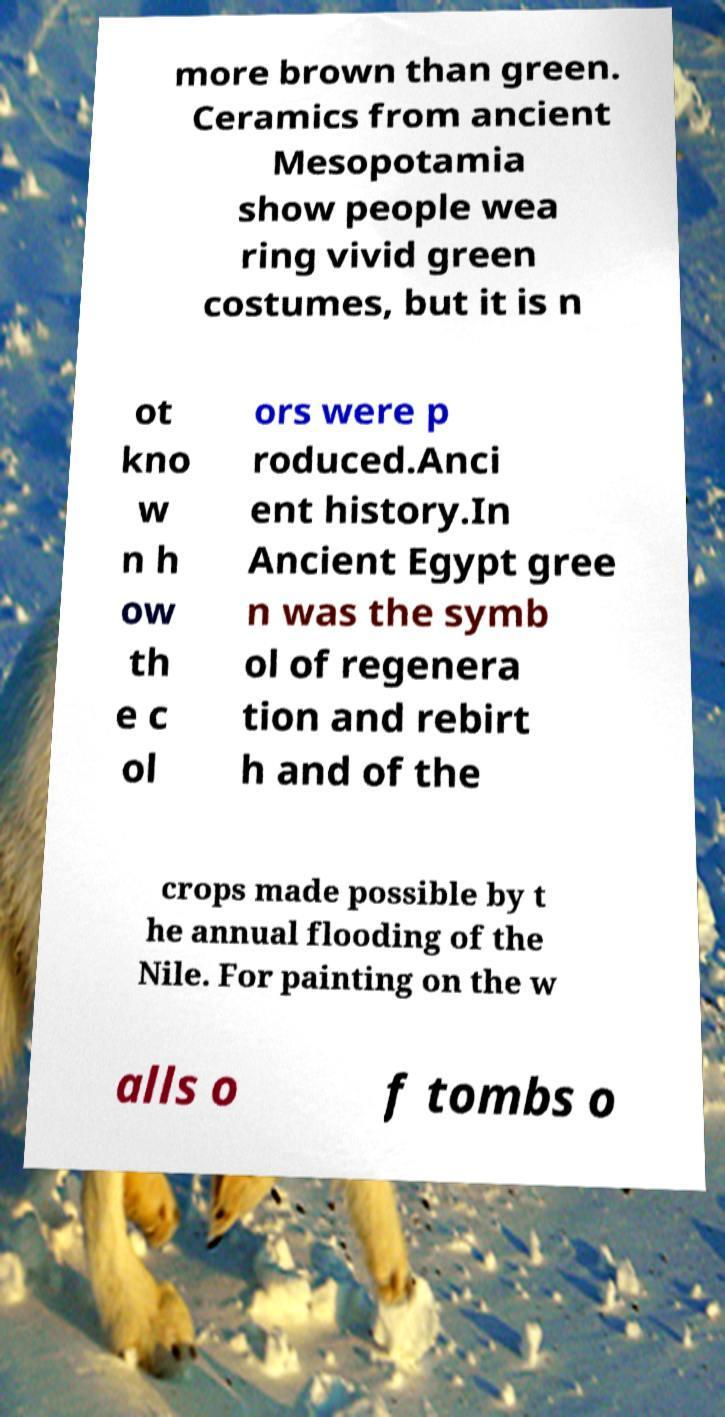Please identify and transcribe the text found in this image. more brown than green. Ceramics from ancient Mesopotamia show people wea ring vivid green costumes, but it is n ot kno w n h ow th e c ol ors were p roduced.Anci ent history.In Ancient Egypt gree n was the symb ol of regenera tion and rebirt h and of the crops made possible by t he annual flooding of the Nile. For painting on the w alls o f tombs o 